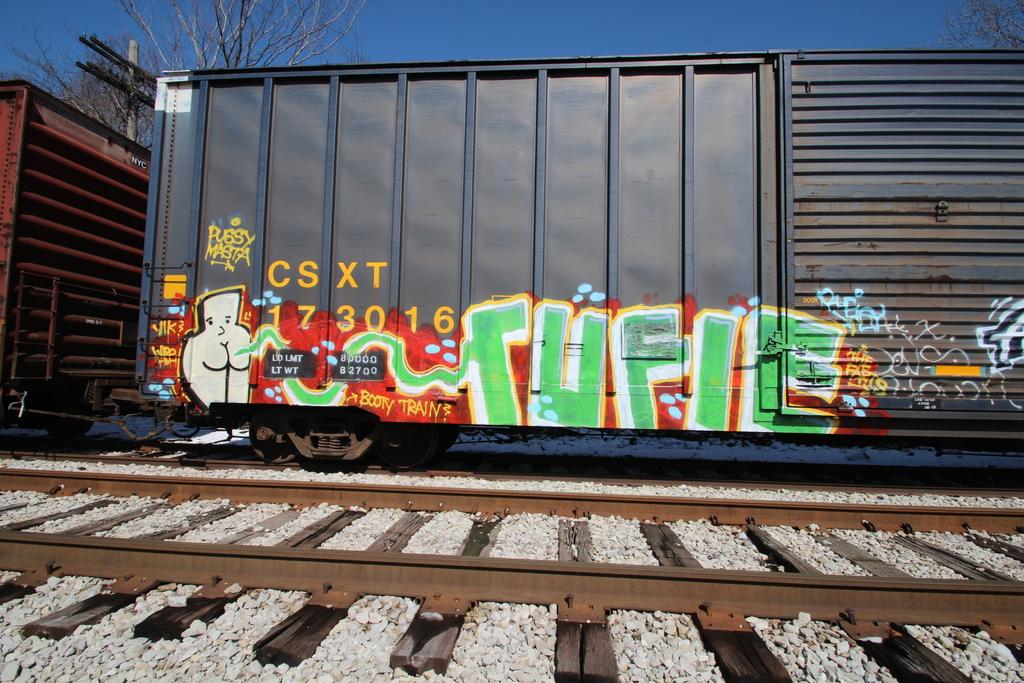<image>
Relay a brief, clear account of the picture shown. Some graffiti on a railway car which is from the company CSXT 